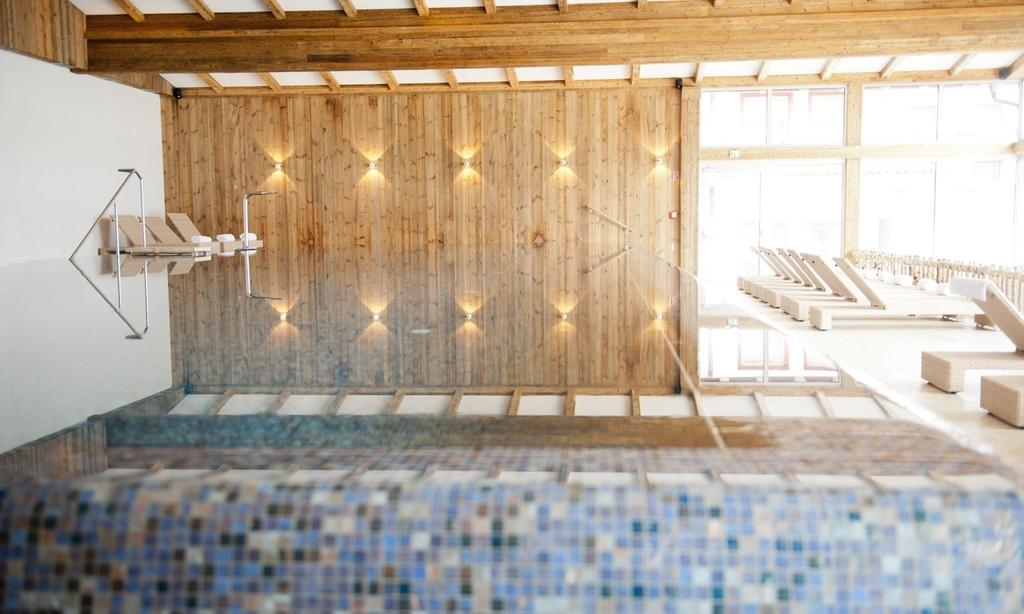What is the color of the wall in the image? The wall in the image is white. What type of material is used for the objects in the image? The objects in the image are made of wood. What is the relationship between the objects and the wall in the image? The objects are attached to the white color wall. What type of nut is used to secure the wooden objects to the wall in the image? There is no mention of nuts or any fastening method in the image; the wooden objects are simply attached to the wall. 